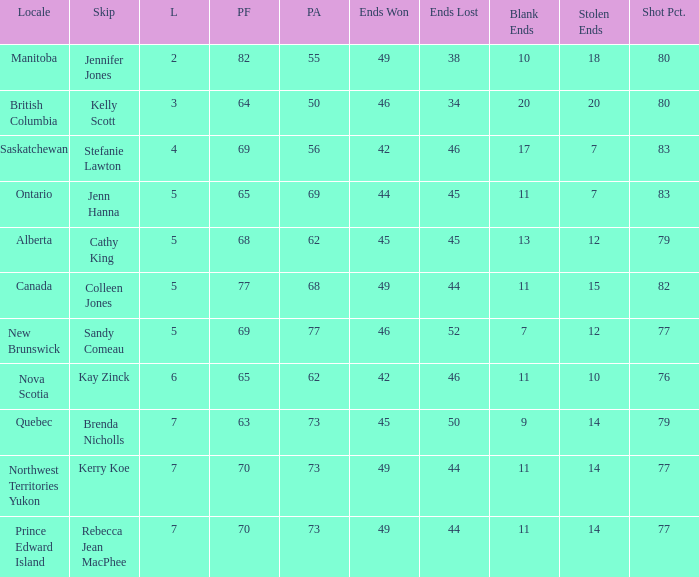What is the lowest PF? 63.0. 